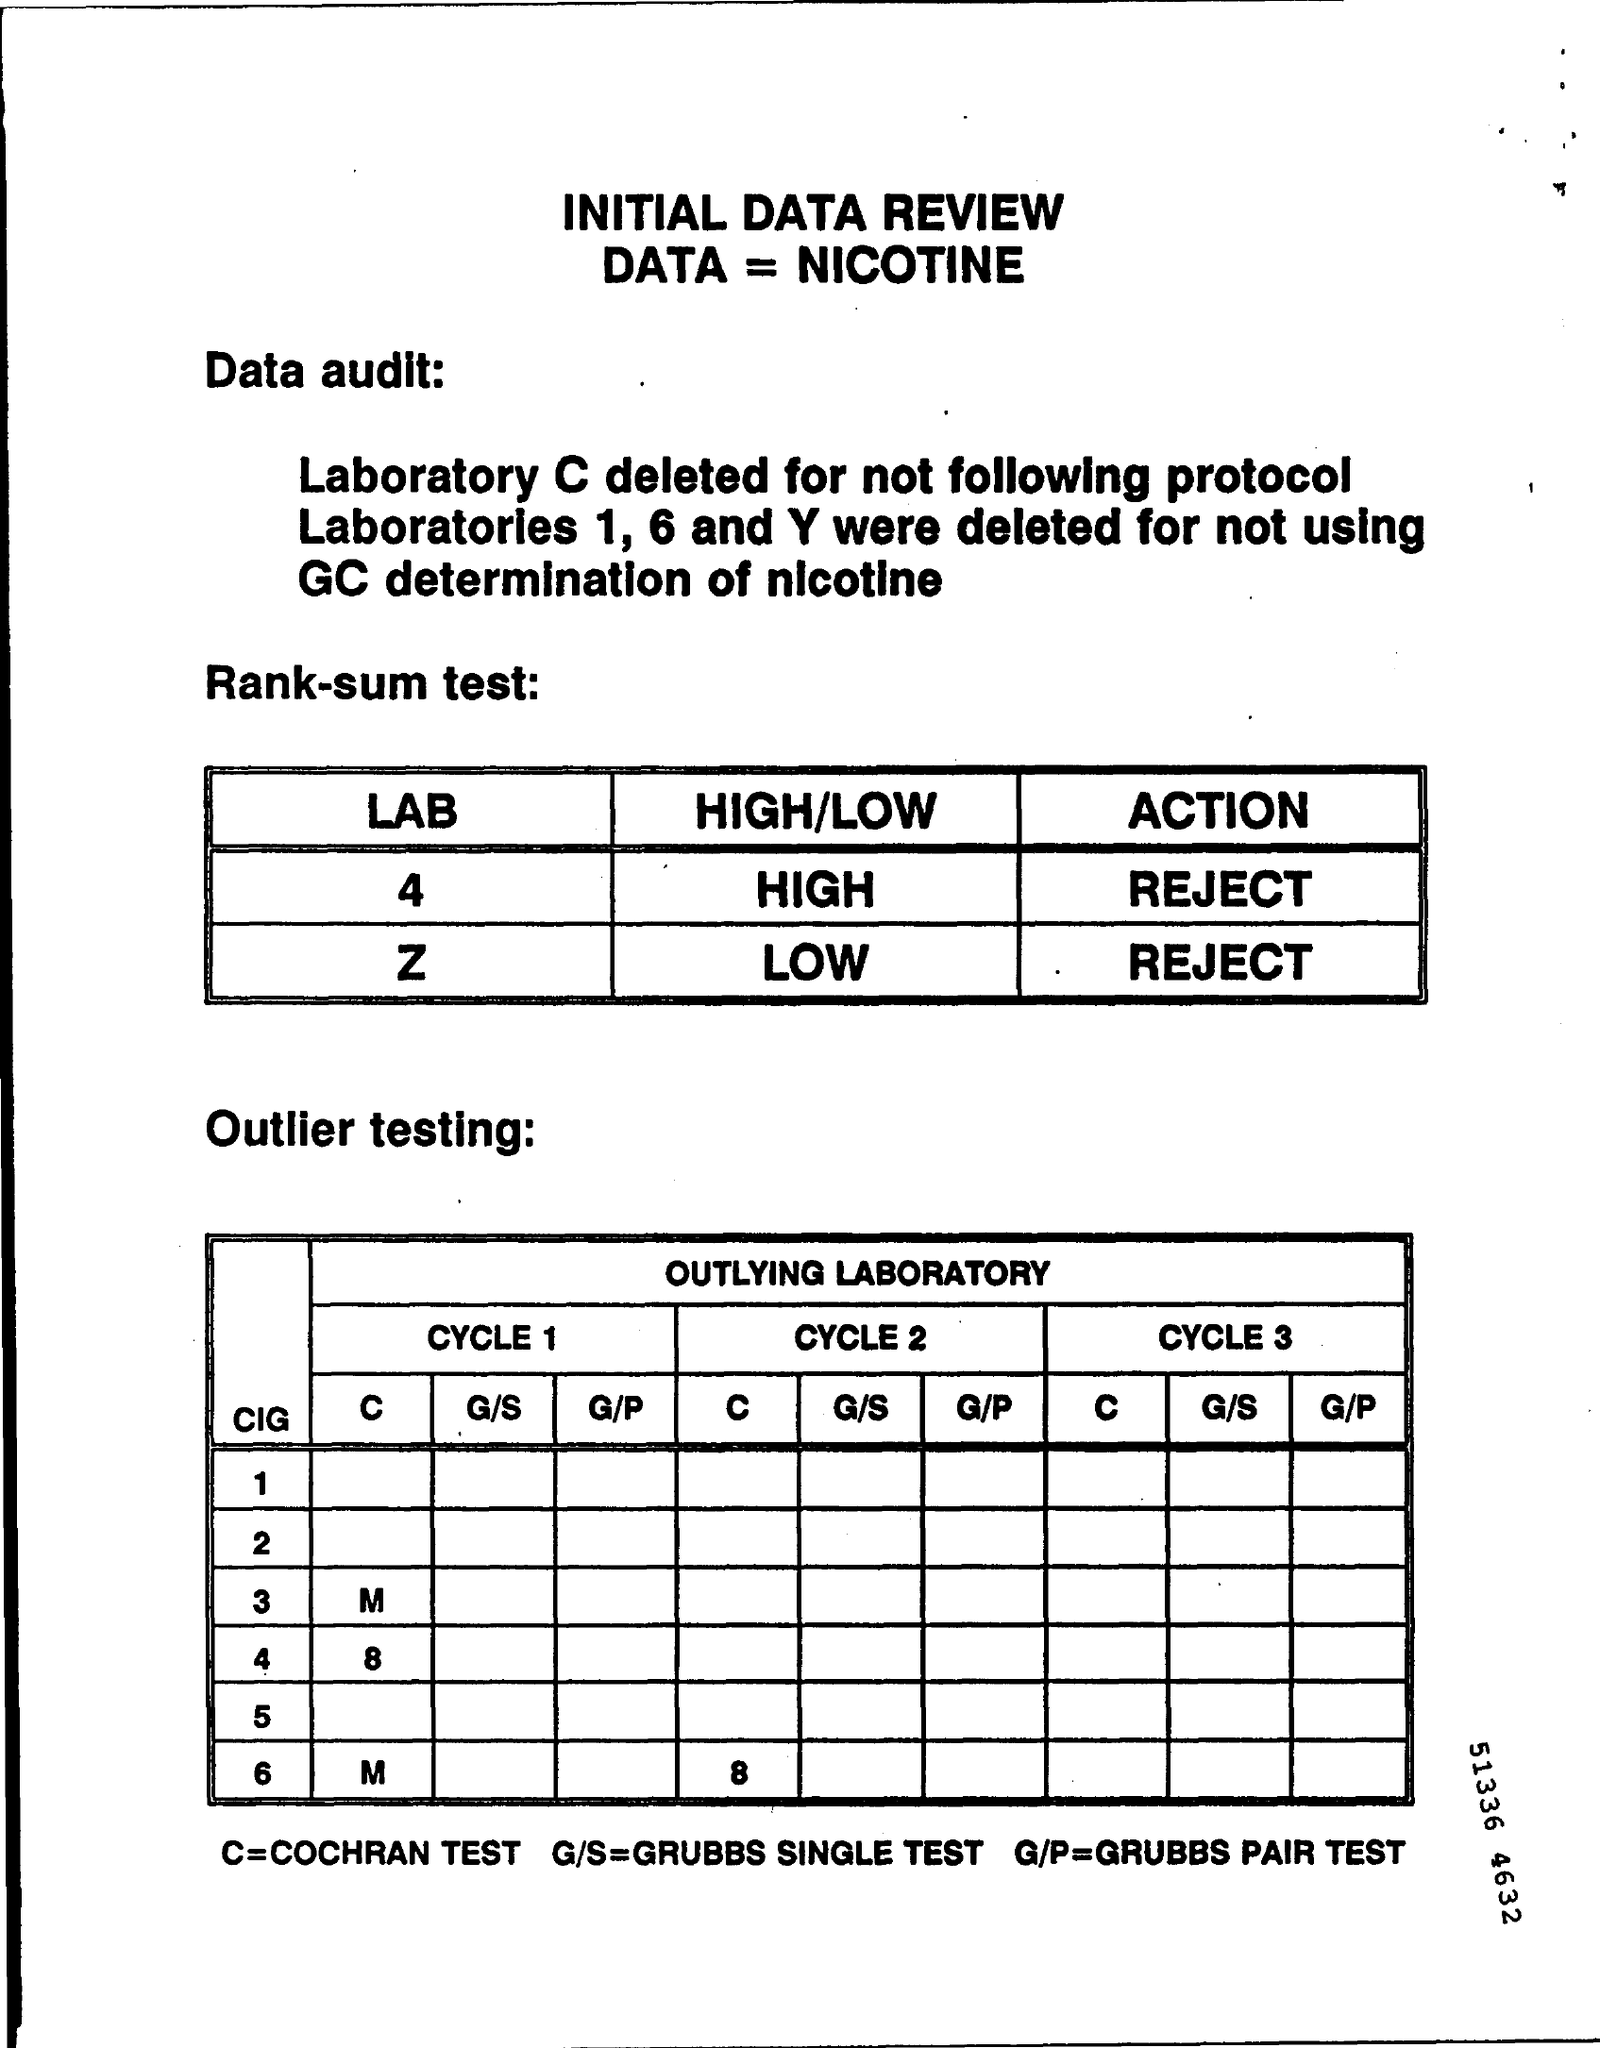Give some essential details in this illustration. Laboratory C was deleted because it did not follow protocol. The document is an initial data review. The term "C" in outlier testing refers to the Cochran test. 